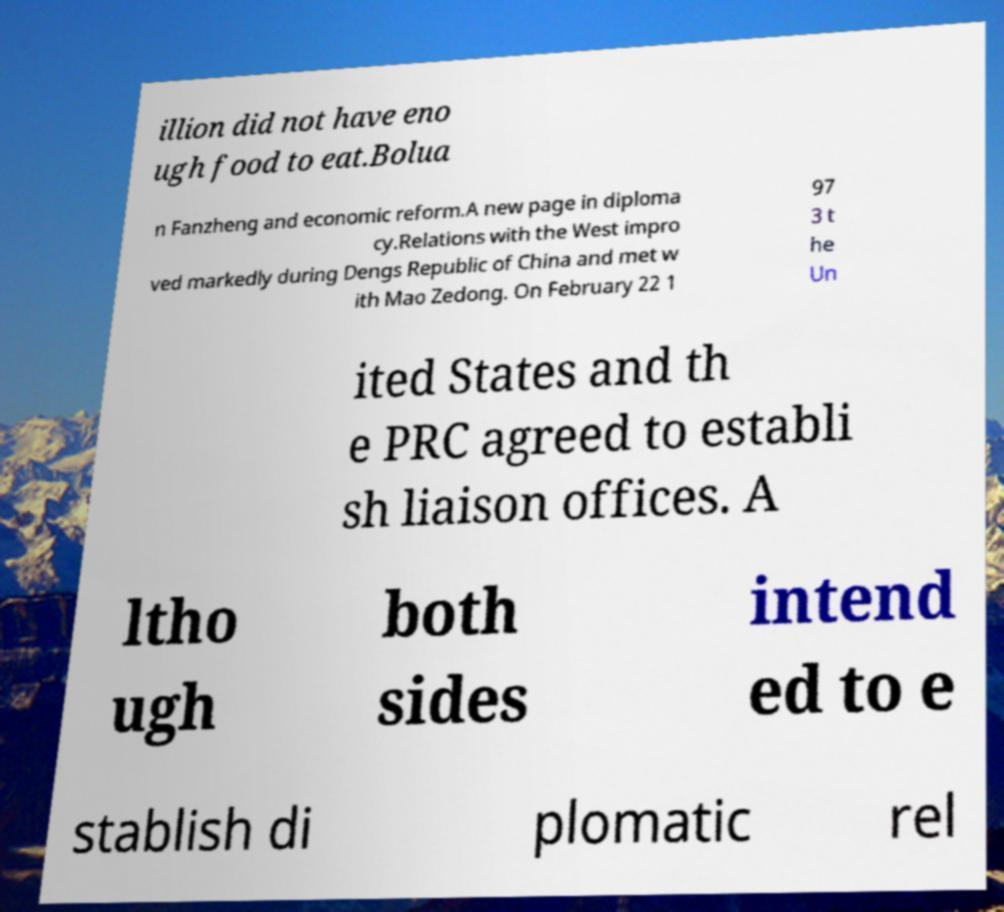Can you accurately transcribe the text from the provided image for me? illion did not have eno ugh food to eat.Bolua n Fanzheng and economic reform.A new page in diploma cy.Relations with the West impro ved markedly during Dengs Republic of China and met w ith Mao Zedong. On February 22 1 97 3 t he Un ited States and th e PRC agreed to establi sh liaison offices. A ltho ugh both sides intend ed to e stablish di plomatic rel 